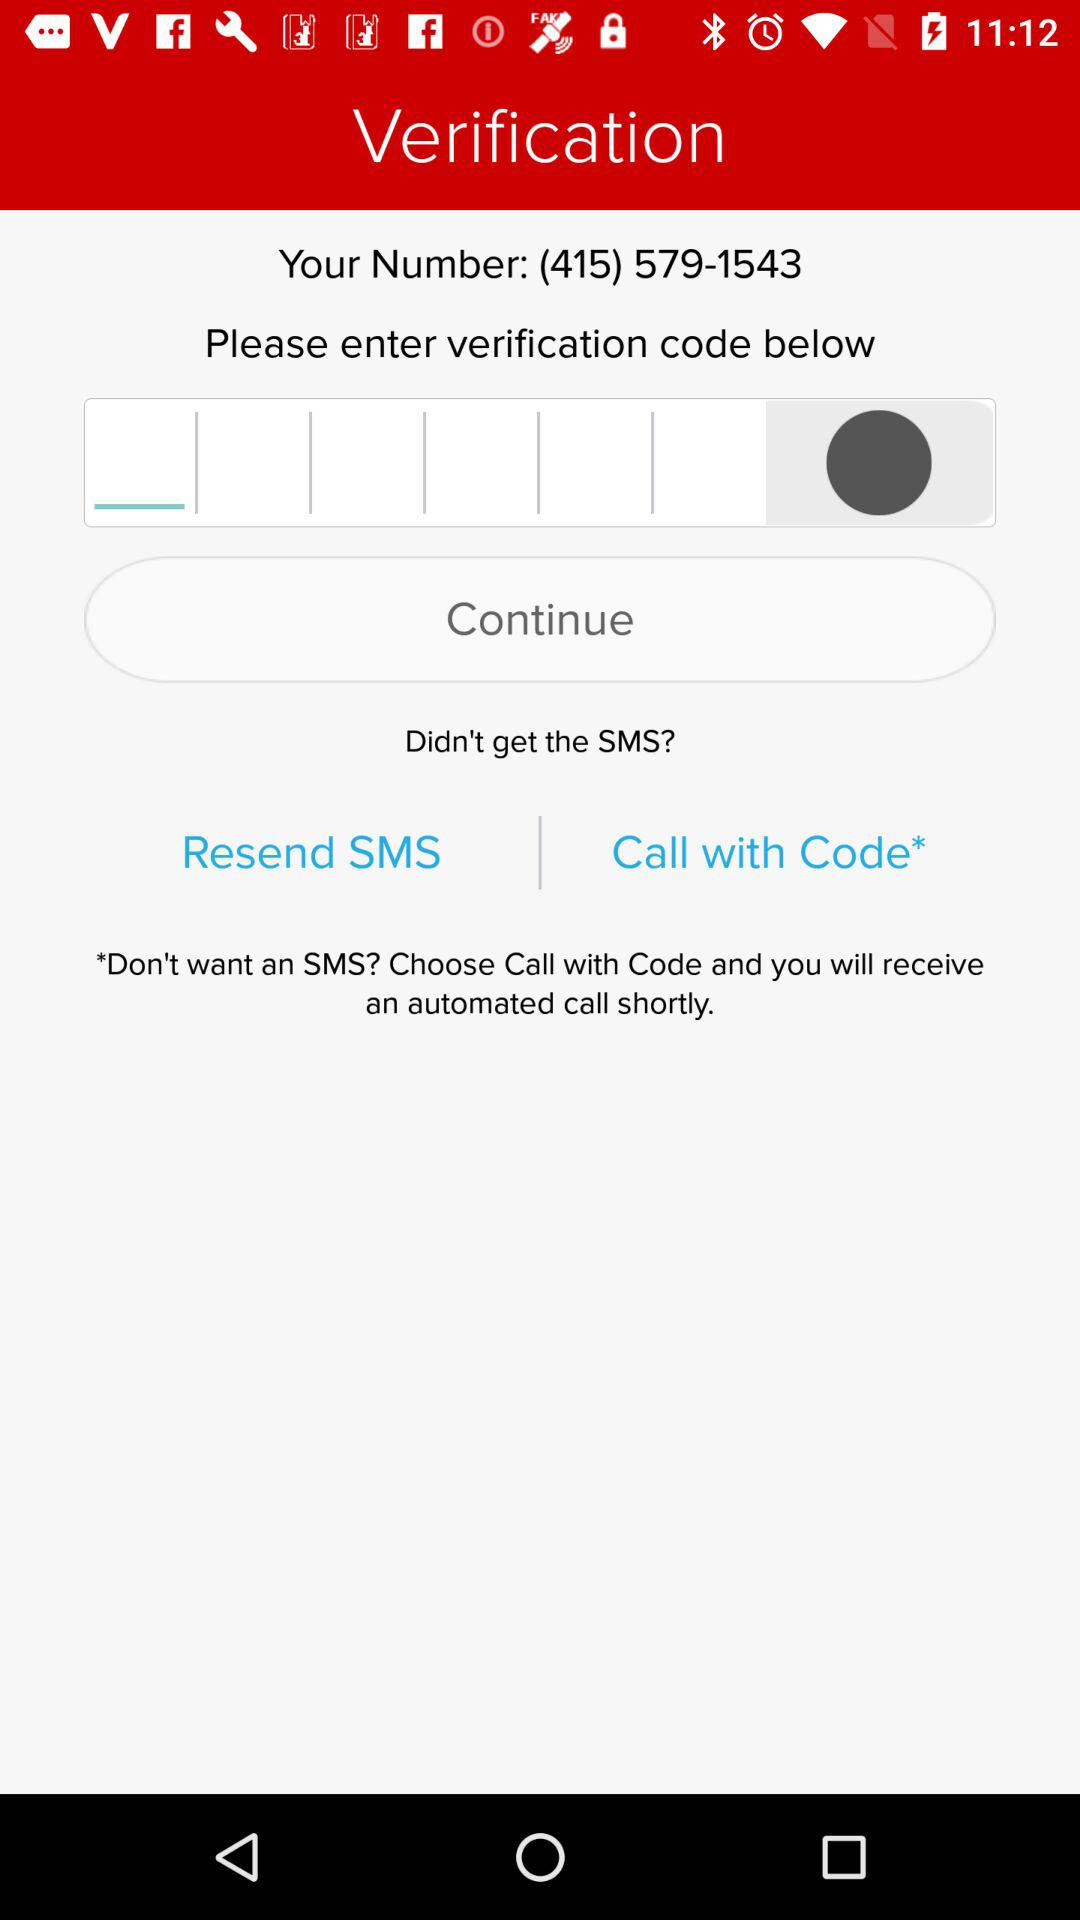What is the contact number? The contact number is (415) 579-1543. 